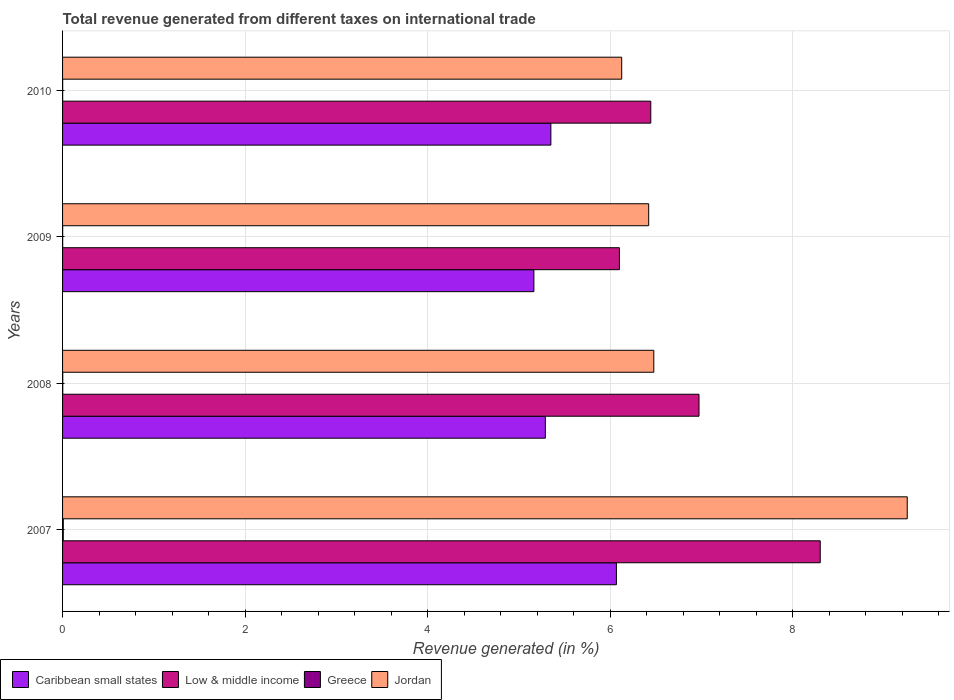How many bars are there on the 1st tick from the bottom?
Ensure brevity in your answer.  4. What is the label of the 2nd group of bars from the top?
Offer a very short reply. 2009. What is the total revenue generated in Greece in 2009?
Give a very brief answer. 0. Across all years, what is the maximum total revenue generated in Caribbean small states?
Provide a short and direct response. 6.07. Across all years, what is the minimum total revenue generated in Jordan?
Give a very brief answer. 6.13. What is the total total revenue generated in Jordan in the graph?
Give a very brief answer. 28.28. What is the difference between the total revenue generated in Greece in 2008 and that in 2009?
Give a very brief answer. 0. What is the difference between the total revenue generated in Caribbean small states in 2008 and the total revenue generated in Low & middle income in 2007?
Your answer should be compact. -3.01. What is the average total revenue generated in Low & middle income per year?
Provide a succinct answer. 6.95. In the year 2009, what is the difference between the total revenue generated in Caribbean small states and total revenue generated in Greece?
Your answer should be compact. 5.16. In how many years, is the total revenue generated in Low & middle income greater than 6.4 %?
Offer a very short reply. 3. What is the ratio of the total revenue generated in Caribbean small states in 2009 to that in 2010?
Provide a short and direct response. 0.97. Is the difference between the total revenue generated in Caribbean small states in 2007 and 2008 greater than the difference between the total revenue generated in Greece in 2007 and 2008?
Your answer should be very brief. Yes. What is the difference between the highest and the second highest total revenue generated in Jordan?
Make the answer very short. 2.78. What is the difference between the highest and the lowest total revenue generated in Low & middle income?
Offer a very short reply. 2.2. Is the sum of the total revenue generated in Low & middle income in 2008 and 2010 greater than the maximum total revenue generated in Jordan across all years?
Your response must be concise. Yes. Is it the case that in every year, the sum of the total revenue generated in Caribbean small states and total revenue generated in Greece is greater than the sum of total revenue generated in Jordan and total revenue generated in Low & middle income?
Make the answer very short. Yes. What does the 1st bar from the top in 2009 represents?
Make the answer very short. Jordan. Is it the case that in every year, the sum of the total revenue generated in Jordan and total revenue generated in Greece is greater than the total revenue generated in Caribbean small states?
Your answer should be very brief. Yes. How many bars are there?
Ensure brevity in your answer.  16. How many years are there in the graph?
Offer a terse response. 4. What is the difference between two consecutive major ticks on the X-axis?
Make the answer very short. 2. Does the graph contain grids?
Your answer should be compact. Yes. Where does the legend appear in the graph?
Your answer should be compact. Bottom left. How are the legend labels stacked?
Your answer should be compact. Horizontal. What is the title of the graph?
Make the answer very short. Total revenue generated from different taxes on international trade. What is the label or title of the X-axis?
Keep it short and to the point. Revenue generated (in %). What is the label or title of the Y-axis?
Make the answer very short. Years. What is the Revenue generated (in %) in Caribbean small states in 2007?
Offer a terse response. 6.07. What is the Revenue generated (in %) in Low & middle income in 2007?
Provide a succinct answer. 8.3. What is the Revenue generated (in %) in Greece in 2007?
Your response must be concise. 0.01. What is the Revenue generated (in %) in Jordan in 2007?
Offer a terse response. 9.25. What is the Revenue generated (in %) in Caribbean small states in 2008?
Ensure brevity in your answer.  5.29. What is the Revenue generated (in %) of Low & middle income in 2008?
Offer a terse response. 6.97. What is the Revenue generated (in %) in Greece in 2008?
Your response must be concise. 0. What is the Revenue generated (in %) in Jordan in 2008?
Keep it short and to the point. 6.48. What is the Revenue generated (in %) of Caribbean small states in 2009?
Ensure brevity in your answer.  5.16. What is the Revenue generated (in %) of Low & middle income in 2009?
Your answer should be compact. 6.1. What is the Revenue generated (in %) of Greece in 2009?
Your answer should be compact. 0. What is the Revenue generated (in %) in Jordan in 2009?
Provide a succinct answer. 6.42. What is the Revenue generated (in %) of Caribbean small states in 2010?
Offer a terse response. 5.35. What is the Revenue generated (in %) in Low & middle income in 2010?
Provide a short and direct response. 6.44. What is the Revenue generated (in %) of Greece in 2010?
Your response must be concise. 0. What is the Revenue generated (in %) in Jordan in 2010?
Provide a succinct answer. 6.13. Across all years, what is the maximum Revenue generated (in %) in Caribbean small states?
Your response must be concise. 6.07. Across all years, what is the maximum Revenue generated (in %) in Low & middle income?
Your answer should be compact. 8.3. Across all years, what is the maximum Revenue generated (in %) in Greece?
Offer a very short reply. 0.01. Across all years, what is the maximum Revenue generated (in %) in Jordan?
Your response must be concise. 9.25. Across all years, what is the minimum Revenue generated (in %) in Caribbean small states?
Provide a short and direct response. 5.16. Across all years, what is the minimum Revenue generated (in %) in Low & middle income?
Your answer should be very brief. 6.1. Across all years, what is the minimum Revenue generated (in %) of Greece?
Make the answer very short. 0. Across all years, what is the minimum Revenue generated (in %) in Jordan?
Make the answer very short. 6.13. What is the total Revenue generated (in %) in Caribbean small states in the graph?
Give a very brief answer. 21.87. What is the total Revenue generated (in %) of Low & middle income in the graph?
Your answer should be very brief. 27.82. What is the total Revenue generated (in %) in Greece in the graph?
Offer a terse response. 0.01. What is the total Revenue generated (in %) of Jordan in the graph?
Keep it short and to the point. 28.28. What is the difference between the Revenue generated (in %) in Caribbean small states in 2007 and that in 2008?
Offer a terse response. 0.78. What is the difference between the Revenue generated (in %) in Low & middle income in 2007 and that in 2008?
Provide a short and direct response. 1.33. What is the difference between the Revenue generated (in %) in Greece in 2007 and that in 2008?
Ensure brevity in your answer.  0.01. What is the difference between the Revenue generated (in %) in Jordan in 2007 and that in 2008?
Offer a terse response. 2.78. What is the difference between the Revenue generated (in %) of Caribbean small states in 2007 and that in 2009?
Ensure brevity in your answer.  0.9. What is the difference between the Revenue generated (in %) of Greece in 2007 and that in 2009?
Give a very brief answer. 0.01. What is the difference between the Revenue generated (in %) of Jordan in 2007 and that in 2009?
Offer a very short reply. 2.83. What is the difference between the Revenue generated (in %) in Caribbean small states in 2007 and that in 2010?
Give a very brief answer. 0.72. What is the difference between the Revenue generated (in %) of Low & middle income in 2007 and that in 2010?
Provide a succinct answer. 1.86. What is the difference between the Revenue generated (in %) of Greece in 2007 and that in 2010?
Offer a very short reply. 0.01. What is the difference between the Revenue generated (in %) in Jordan in 2007 and that in 2010?
Offer a terse response. 3.13. What is the difference between the Revenue generated (in %) of Caribbean small states in 2008 and that in 2009?
Your response must be concise. 0.13. What is the difference between the Revenue generated (in %) in Low & middle income in 2008 and that in 2009?
Your answer should be very brief. 0.87. What is the difference between the Revenue generated (in %) in Greece in 2008 and that in 2009?
Your answer should be compact. 0. What is the difference between the Revenue generated (in %) of Jordan in 2008 and that in 2009?
Keep it short and to the point. 0.06. What is the difference between the Revenue generated (in %) in Caribbean small states in 2008 and that in 2010?
Provide a succinct answer. -0.06. What is the difference between the Revenue generated (in %) of Low & middle income in 2008 and that in 2010?
Provide a short and direct response. 0.53. What is the difference between the Revenue generated (in %) in Jordan in 2008 and that in 2010?
Your response must be concise. 0.35. What is the difference between the Revenue generated (in %) in Caribbean small states in 2009 and that in 2010?
Offer a very short reply. -0.19. What is the difference between the Revenue generated (in %) in Low & middle income in 2009 and that in 2010?
Your answer should be very brief. -0.34. What is the difference between the Revenue generated (in %) of Jordan in 2009 and that in 2010?
Make the answer very short. 0.3. What is the difference between the Revenue generated (in %) in Caribbean small states in 2007 and the Revenue generated (in %) in Low & middle income in 2008?
Your response must be concise. -0.9. What is the difference between the Revenue generated (in %) of Caribbean small states in 2007 and the Revenue generated (in %) of Greece in 2008?
Keep it short and to the point. 6.07. What is the difference between the Revenue generated (in %) in Caribbean small states in 2007 and the Revenue generated (in %) in Jordan in 2008?
Your answer should be very brief. -0.41. What is the difference between the Revenue generated (in %) of Low & middle income in 2007 and the Revenue generated (in %) of Greece in 2008?
Ensure brevity in your answer.  8.3. What is the difference between the Revenue generated (in %) in Low & middle income in 2007 and the Revenue generated (in %) in Jordan in 2008?
Offer a very short reply. 1.82. What is the difference between the Revenue generated (in %) of Greece in 2007 and the Revenue generated (in %) of Jordan in 2008?
Provide a short and direct response. -6.47. What is the difference between the Revenue generated (in %) in Caribbean small states in 2007 and the Revenue generated (in %) in Low & middle income in 2009?
Your answer should be very brief. -0.03. What is the difference between the Revenue generated (in %) of Caribbean small states in 2007 and the Revenue generated (in %) of Greece in 2009?
Offer a very short reply. 6.07. What is the difference between the Revenue generated (in %) in Caribbean small states in 2007 and the Revenue generated (in %) in Jordan in 2009?
Offer a terse response. -0.35. What is the difference between the Revenue generated (in %) of Low & middle income in 2007 and the Revenue generated (in %) of Greece in 2009?
Offer a terse response. 8.3. What is the difference between the Revenue generated (in %) of Low & middle income in 2007 and the Revenue generated (in %) of Jordan in 2009?
Provide a succinct answer. 1.88. What is the difference between the Revenue generated (in %) in Greece in 2007 and the Revenue generated (in %) in Jordan in 2009?
Provide a short and direct response. -6.41. What is the difference between the Revenue generated (in %) of Caribbean small states in 2007 and the Revenue generated (in %) of Low & middle income in 2010?
Keep it short and to the point. -0.38. What is the difference between the Revenue generated (in %) in Caribbean small states in 2007 and the Revenue generated (in %) in Greece in 2010?
Make the answer very short. 6.07. What is the difference between the Revenue generated (in %) in Caribbean small states in 2007 and the Revenue generated (in %) in Jordan in 2010?
Your answer should be compact. -0.06. What is the difference between the Revenue generated (in %) of Low & middle income in 2007 and the Revenue generated (in %) of Greece in 2010?
Your answer should be very brief. 8.3. What is the difference between the Revenue generated (in %) of Low & middle income in 2007 and the Revenue generated (in %) of Jordan in 2010?
Offer a very short reply. 2.17. What is the difference between the Revenue generated (in %) in Greece in 2007 and the Revenue generated (in %) in Jordan in 2010?
Keep it short and to the point. -6.12. What is the difference between the Revenue generated (in %) of Caribbean small states in 2008 and the Revenue generated (in %) of Low & middle income in 2009?
Your response must be concise. -0.81. What is the difference between the Revenue generated (in %) in Caribbean small states in 2008 and the Revenue generated (in %) in Greece in 2009?
Offer a terse response. 5.29. What is the difference between the Revenue generated (in %) in Caribbean small states in 2008 and the Revenue generated (in %) in Jordan in 2009?
Make the answer very short. -1.13. What is the difference between the Revenue generated (in %) of Low & middle income in 2008 and the Revenue generated (in %) of Greece in 2009?
Provide a succinct answer. 6.97. What is the difference between the Revenue generated (in %) of Low & middle income in 2008 and the Revenue generated (in %) of Jordan in 2009?
Give a very brief answer. 0.55. What is the difference between the Revenue generated (in %) in Greece in 2008 and the Revenue generated (in %) in Jordan in 2009?
Provide a short and direct response. -6.42. What is the difference between the Revenue generated (in %) of Caribbean small states in 2008 and the Revenue generated (in %) of Low & middle income in 2010?
Ensure brevity in your answer.  -1.16. What is the difference between the Revenue generated (in %) in Caribbean small states in 2008 and the Revenue generated (in %) in Greece in 2010?
Offer a very short reply. 5.29. What is the difference between the Revenue generated (in %) in Caribbean small states in 2008 and the Revenue generated (in %) in Jordan in 2010?
Ensure brevity in your answer.  -0.84. What is the difference between the Revenue generated (in %) in Low & middle income in 2008 and the Revenue generated (in %) in Greece in 2010?
Keep it short and to the point. 6.97. What is the difference between the Revenue generated (in %) in Low & middle income in 2008 and the Revenue generated (in %) in Jordan in 2010?
Your answer should be very brief. 0.85. What is the difference between the Revenue generated (in %) in Greece in 2008 and the Revenue generated (in %) in Jordan in 2010?
Provide a short and direct response. -6.12. What is the difference between the Revenue generated (in %) in Caribbean small states in 2009 and the Revenue generated (in %) in Low & middle income in 2010?
Provide a succinct answer. -1.28. What is the difference between the Revenue generated (in %) of Caribbean small states in 2009 and the Revenue generated (in %) of Greece in 2010?
Provide a short and direct response. 5.16. What is the difference between the Revenue generated (in %) in Caribbean small states in 2009 and the Revenue generated (in %) in Jordan in 2010?
Your answer should be compact. -0.96. What is the difference between the Revenue generated (in %) in Low & middle income in 2009 and the Revenue generated (in %) in Greece in 2010?
Your answer should be very brief. 6.1. What is the difference between the Revenue generated (in %) in Low & middle income in 2009 and the Revenue generated (in %) in Jordan in 2010?
Offer a terse response. -0.03. What is the difference between the Revenue generated (in %) in Greece in 2009 and the Revenue generated (in %) in Jordan in 2010?
Give a very brief answer. -6.12. What is the average Revenue generated (in %) in Caribbean small states per year?
Keep it short and to the point. 5.47. What is the average Revenue generated (in %) in Low & middle income per year?
Keep it short and to the point. 6.95. What is the average Revenue generated (in %) in Greece per year?
Offer a terse response. 0. What is the average Revenue generated (in %) in Jordan per year?
Make the answer very short. 7.07. In the year 2007, what is the difference between the Revenue generated (in %) of Caribbean small states and Revenue generated (in %) of Low & middle income?
Your answer should be compact. -2.23. In the year 2007, what is the difference between the Revenue generated (in %) in Caribbean small states and Revenue generated (in %) in Greece?
Make the answer very short. 6.06. In the year 2007, what is the difference between the Revenue generated (in %) in Caribbean small states and Revenue generated (in %) in Jordan?
Offer a terse response. -3.19. In the year 2007, what is the difference between the Revenue generated (in %) of Low & middle income and Revenue generated (in %) of Greece?
Make the answer very short. 8.29. In the year 2007, what is the difference between the Revenue generated (in %) in Low & middle income and Revenue generated (in %) in Jordan?
Your answer should be very brief. -0.95. In the year 2007, what is the difference between the Revenue generated (in %) of Greece and Revenue generated (in %) of Jordan?
Your answer should be very brief. -9.25. In the year 2008, what is the difference between the Revenue generated (in %) of Caribbean small states and Revenue generated (in %) of Low & middle income?
Give a very brief answer. -1.68. In the year 2008, what is the difference between the Revenue generated (in %) of Caribbean small states and Revenue generated (in %) of Greece?
Offer a terse response. 5.29. In the year 2008, what is the difference between the Revenue generated (in %) in Caribbean small states and Revenue generated (in %) in Jordan?
Offer a very short reply. -1.19. In the year 2008, what is the difference between the Revenue generated (in %) in Low & middle income and Revenue generated (in %) in Greece?
Your response must be concise. 6.97. In the year 2008, what is the difference between the Revenue generated (in %) of Low & middle income and Revenue generated (in %) of Jordan?
Offer a terse response. 0.5. In the year 2008, what is the difference between the Revenue generated (in %) of Greece and Revenue generated (in %) of Jordan?
Your answer should be very brief. -6.47. In the year 2009, what is the difference between the Revenue generated (in %) in Caribbean small states and Revenue generated (in %) in Low & middle income?
Keep it short and to the point. -0.94. In the year 2009, what is the difference between the Revenue generated (in %) in Caribbean small states and Revenue generated (in %) in Greece?
Keep it short and to the point. 5.16. In the year 2009, what is the difference between the Revenue generated (in %) in Caribbean small states and Revenue generated (in %) in Jordan?
Your response must be concise. -1.26. In the year 2009, what is the difference between the Revenue generated (in %) of Low & middle income and Revenue generated (in %) of Greece?
Your answer should be very brief. 6.1. In the year 2009, what is the difference between the Revenue generated (in %) in Low & middle income and Revenue generated (in %) in Jordan?
Make the answer very short. -0.32. In the year 2009, what is the difference between the Revenue generated (in %) of Greece and Revenue generated (in %) of Jordan?
Give a very brief answer. -6.42. In the year 2010, what is the difference between the Revenue generated (in %) in Caribbean small states and Revenue generated (in %) in Low & middle income?
Your response must be concise. -1.09. In the year 2010, what is the difference between the Revenue generated (in %) in Caribbean small states and Revenue generated (in %) in Greece?
Ensure brevity in your answer.  5.35. In the year 2010, what is the difference between the Revenue generated (in %) of Caribbean small states and Revenue generated (in %) of Jordan?
Your response must be concise. -0.78. In the year 2010, what is the difference between the Revenue generated (in %) of Low & middle income and Revenue generated (in %) of Greece?
Your answer should be very brief. 6.44. In the year 2010, what is the difference between the Revenue generated (in %) of Low & middle income and Revenue generated (in %) of Jordan?
Offer a very short reply. 0.32. In the year 2010, what is the difference between the Revenue generated (in %) of Greece and Revenue generated (in %) of Jordan?
Your answer should be very brief. -6.12. What is the ratio of the Revenue generated (in %) of Caribbean small states in 2007 to that in 2008?
Keep it short and to the point. 1.15. What is the ratio of the Revenue generated (in %) of Low & middle income in 2007 to that in 2008?
Provide a succinct answer. 1.19. What is the ratio of the Revenue generated (in %) in Greece in 2007 to that in 2008?
Your response must be concise. 3.65. What is the ratio of the Revenue generated (in %) in Jordan in 2007 to that in 2008?
Offer a very short reply. 1.43. What is the ratio of the Revenue generated (in %) of Caribbean small states in 2007 to that in 2009?
Your answer should be very brief. 1.18. What is the ratio of the Revenue generated (in %) in Low & middle income in 2007 to that in 2009?
Provide a short and direct response. 1.36. What is the ratio of the Revenue generated (in %) in Greece in 2007 to that in 2009?
Ensure brevity in your answer.  6.79. What is the ratio of the Revenue generated (in %) in Jordan in 2007 to that in 2009?
Offer a terse response. 1.44. What is the ratio of the Revenue generated (in %) of Caribbean small states in 2007 to that in 2010?
Keep it short and to the point. 1.13. What is the ratio of the Revenue generated (in %) in Low & middle income in 2007 to that in 2010?
Offer a terse response. 1.29. What is the ratio of the Revenue generated (in %) in Greece in 2007 to that in 2010?
Offer a terse response. 6.91. What is the ratio of the Revenue generated (in %) of Jordan in 2007 to that in 2010?
Keep it short and to the point. 1.51. What is the ratio of the Revenue generated (in %) of Caribbean small states in 2008 to that in 2009?
Make the answer very short. 1.02. What is the ratio of the Revenue generated (in %) in Low & middle income in 2008 to that in 2009?
Your answer should be very brief. 1.14. What is the ratio of the Revenue generated (in %) of Greece in 2008 to that in 2009?
Ensure brevity in your answer.  1.86. What is the ratio of the Revenue generated (in %) in Jordan in 2008 to that in 2009?
Offer a very short reply. 1.01. What is the ratio of the Revenue generated (in %) of Caribbean small states in 2008 to that in 2010?
Your response must be concise. 0.99. What is the ratio of the Revenue generated (in %) in Low & middle income in 2008 to that in 2010?
Keep it short and to the point. 1.08. What is the ratio of the Revenue generated (in %) of Greece in 2008 to that in 2010?
Give a very brief answer. 1.89. What is the ratio of the Revenue generated (in %) of Jordan in 2008 to that in 2010?
Keep it short and to the point. 1.06. What is the ratio of the Revenue generated (in %) of Caribbean small states in 2009 to that in 2010?
Offer a very short reply. 0.97. What is the ratio of the Revenue generated (in %) of Low & middle income in 2009 to that in 2010?
Your response must be concise. 0.95. What is the ratio of the Revenue generated (in %) in Greece in 2009 to that in 2010?
Your response must be concise. 1.02. What is the ratio of the Revenue generated (in %) of Jordan in 2009 to that in 2010?
Offer a terse response. 1.05. What is the difference between the highest and the second highest Revenue generated (in %) in Caribbean small states?
Give a very brief answer. 0.72. What is the difference between the highest and the second highest Revenue generated (in %) of Low & middle income?
Ensure brevity in your answer.  1.33. What is the difference between the highest and the second highest Revenue generated (in %) in Greece?
Provide a short and direct response. 0.01. What is the difference between the highest and the second highest Revenue generated (in %) in Jordan?
Give a very brief answer. 2.78. What is the difference between the highest and the lowest Revenue generated (in %) of Caribbean small states?
Your answer should be compact. 0.9. What is the difference between the highest and the lowest Revenue generated (in %) of Greece?
Provide a short and direct response. 0.01. What is the difference between the highest and the lowest Revenue generated (in %) in Jordan?
Offer a terse response. 3.13. 